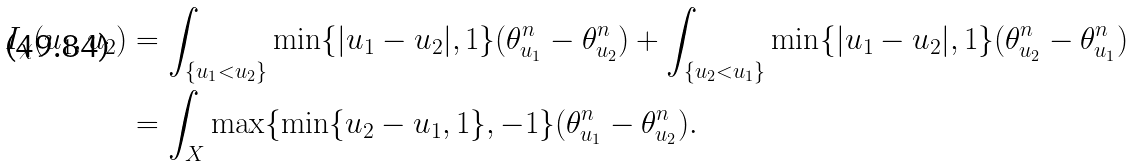Convert formula to latex. <formula><loc_0><loc_0><loc_500><loc_500>I _ { \chi } ( u _ { 1 } , u _ { 2 } ) & = \int _ { \{ u _ { 1 } < u _ { 2 } \} } \min \{ | u _ { 1 } - u _ { 2 } | , 1 \} ( \theta _ { u _ { 1 } } ^ { n } - \theta _ { u _ { 2 } } ^ { n } ) + \int _ { \{ u _ { 2 } < u _ { 1 } \} } \min \{ | u _ { 1 } - u _ { 2 } | , 1 \} ( \theta _ { u _ { 2 } } ^ { n } - \theta _ { u _ { 1 } } ^ { n } ) \\ & = \int _ { X } \max \{ \min \{ u _ { 2 } - u _ { 1 } , 1 \} , - 1 \} ( \theta _ { u _ { 1 } } ^ { n } - \theta _ { u _ { 2 } } ^ { n } ) .</formula> 